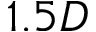Convert formula to latex. <formula><loc_0><loc_0><loc_500><loc_500>1 . 5 D</formula> 